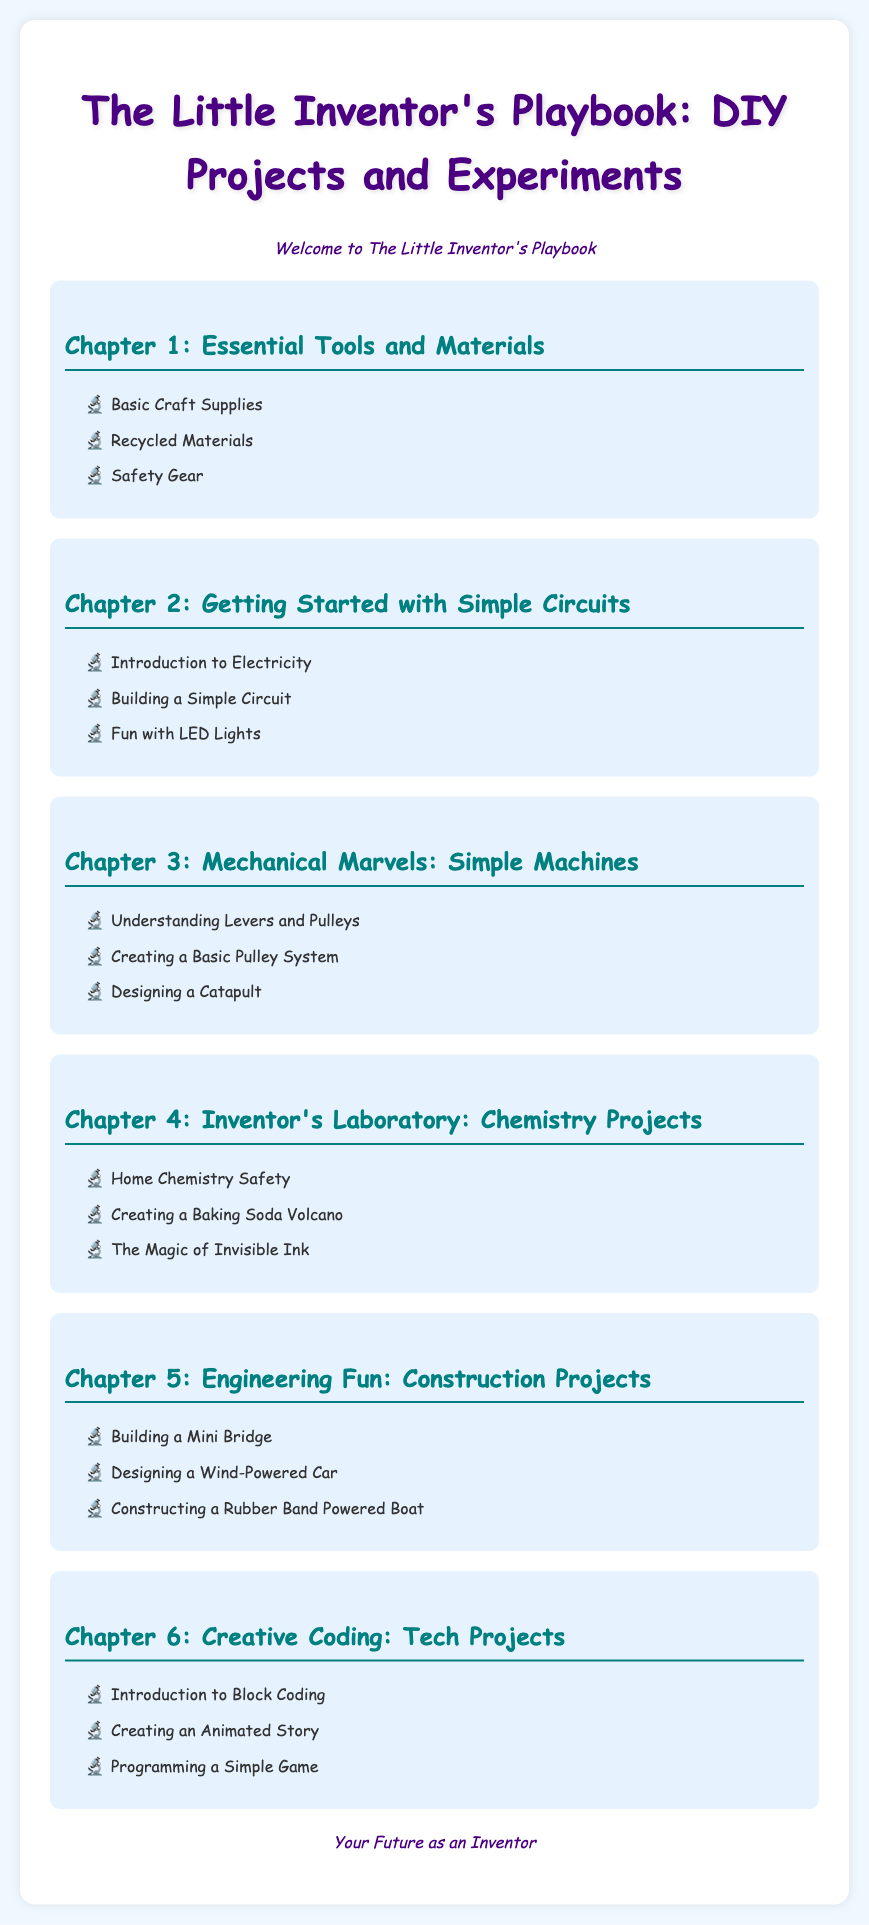What is the title of the playbook? The title of the playbook is found at the top of the document.
Answer: The Little Inventor's Playbook: DIY Projects and Experiments How many chapters are in the document? The document lists the chapters from 1 to 6, indicating the total number of chapters.
Answer: 6 What is the focus of Chapter 3? The title of Chapter 3 provides the focus of its content.
Answer: Mechanical Marvels: Simple Machines Which project involves colorless ink? The project mentioned in Chapter 4 relates to this concept.
Answer: The Magic of Invisible Ink What is the first topic in Chapter 2? The first topic in Chapter 2 is mentioned in the list of its contents.
Answer: Introduction to Electricity What is emphasized in the introduction? The introduction contains a welcoming message to the reader.
Answer: Welcome to The Little Inventor's Playbook What type of safety is discussed in Chapter 4? The subject of safety in Chapter 4 is related to a specific area of experimentation.
Answer: Home Chemistry Safety What unique project is offered in Chapter 5? A distinctive construction project is listed in Chapter 5's content.
Answer: Designing a Wind-Powered Car 